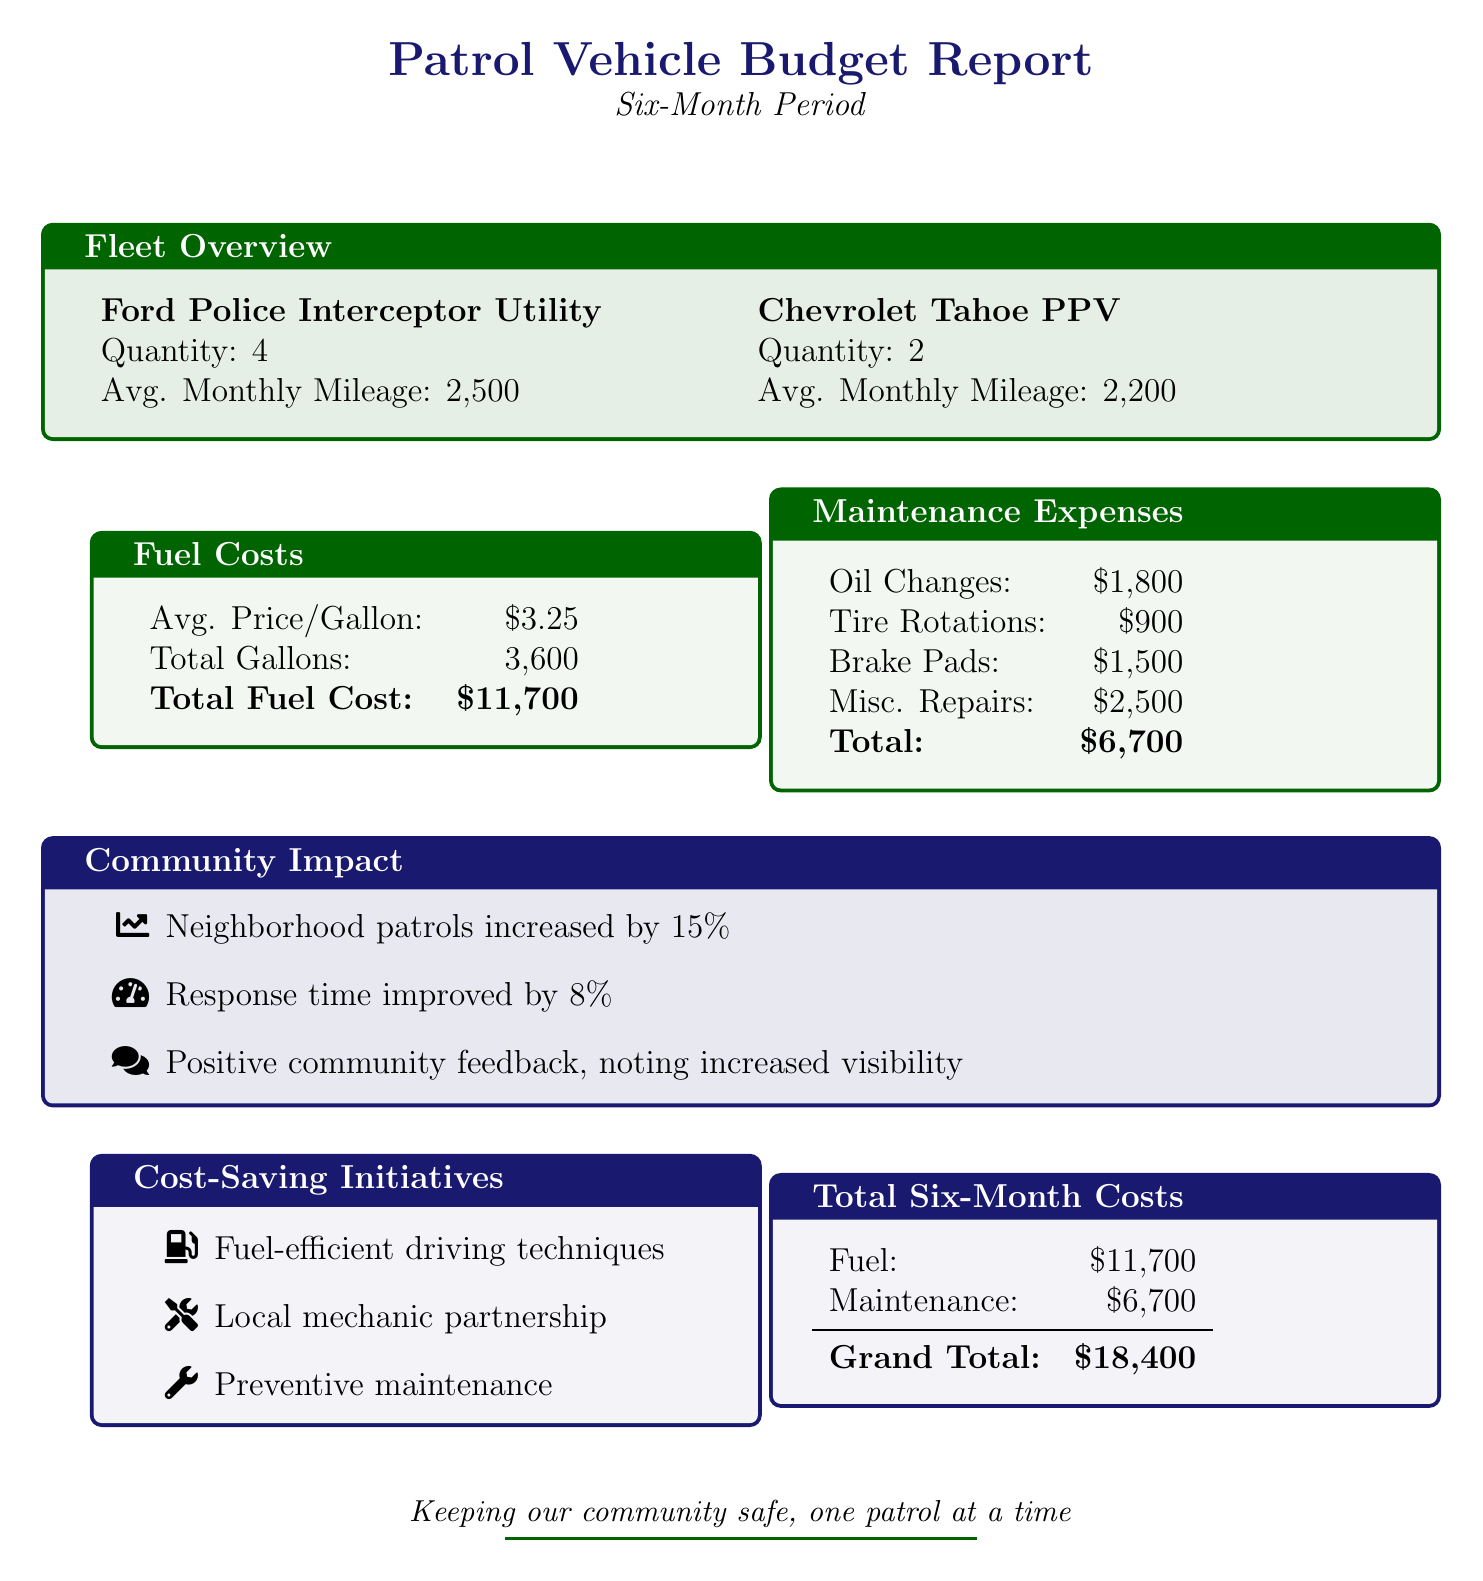What is the total fuel cost? The total fuel cost is explicitly listed in the document as \$11,700.
Answer: \$11,700 How many Ford Police Interceptor Utilities are in the fleet? The document specifies that there are 4 Ford Police Interceptor Utilities in the fleet.
Answer: 4 What was the average monthly mileage for Chevrolet Tahoe PPV? The document states that the average monthly mileage for Chevrolet Tahoe PPV is 2,200.
Answer: 2,200 What is the total amount spent on maintenance expenses? The total maintenance expenses are provided in the document as \$6,700.
Answer: \$6,700 By what percentage did neighborhood patrols increase? The document indicates that neighborhood patrols increased by 15%.
Answer: 15% What is the average price per gallon of fuel? The document lists the average price per gallon of fuel as \$3.25.
Answer: \$3.25 What is the total amount allocated for oil changes? The total amount allocated for oil changes is stated as \$1,800.
Answer: \$1,800 How much did response time improve by? The document mentions that response time improved by 8%.
Answer: 8% What is the grand total of six-month costs? The grand total of six-month costs is explicitly stated in the document as \$18,400.
Answer: \$18,400 